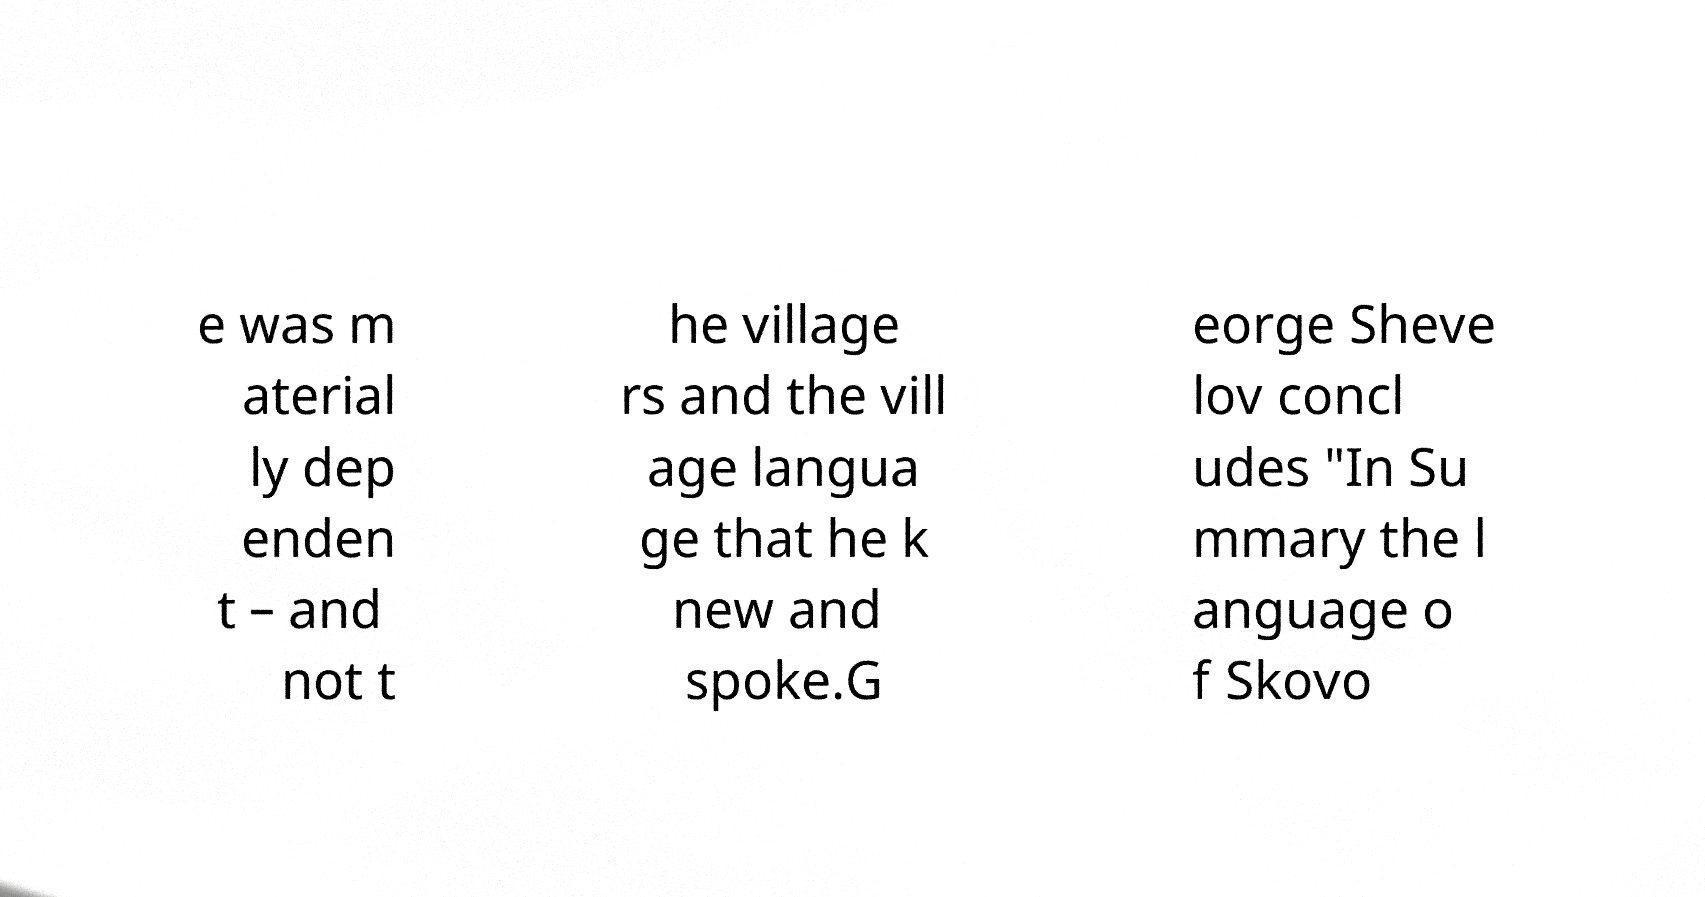I need the written content from this picture converted into text. Can you do that? e was m aterial ly dep enden t – and not t he village rs and the vill age langua ge that he k new and spoke.G eorge Sheve lov concl udes ″In Su mmary the l anguage o f Skovo 